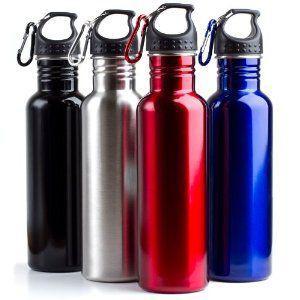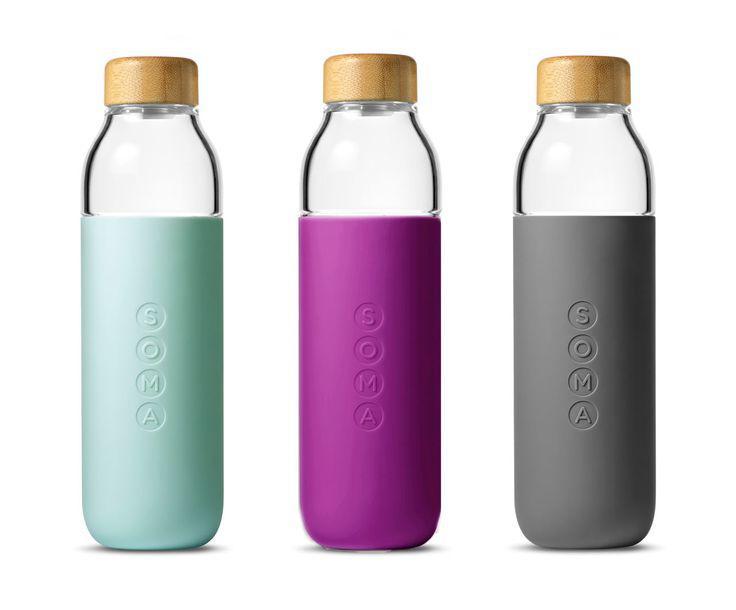The first image is the image on the left, the second image is the image on the right. For the images shown, is this caption "There are seven bottles." true? Answer yes or no. Yes. 